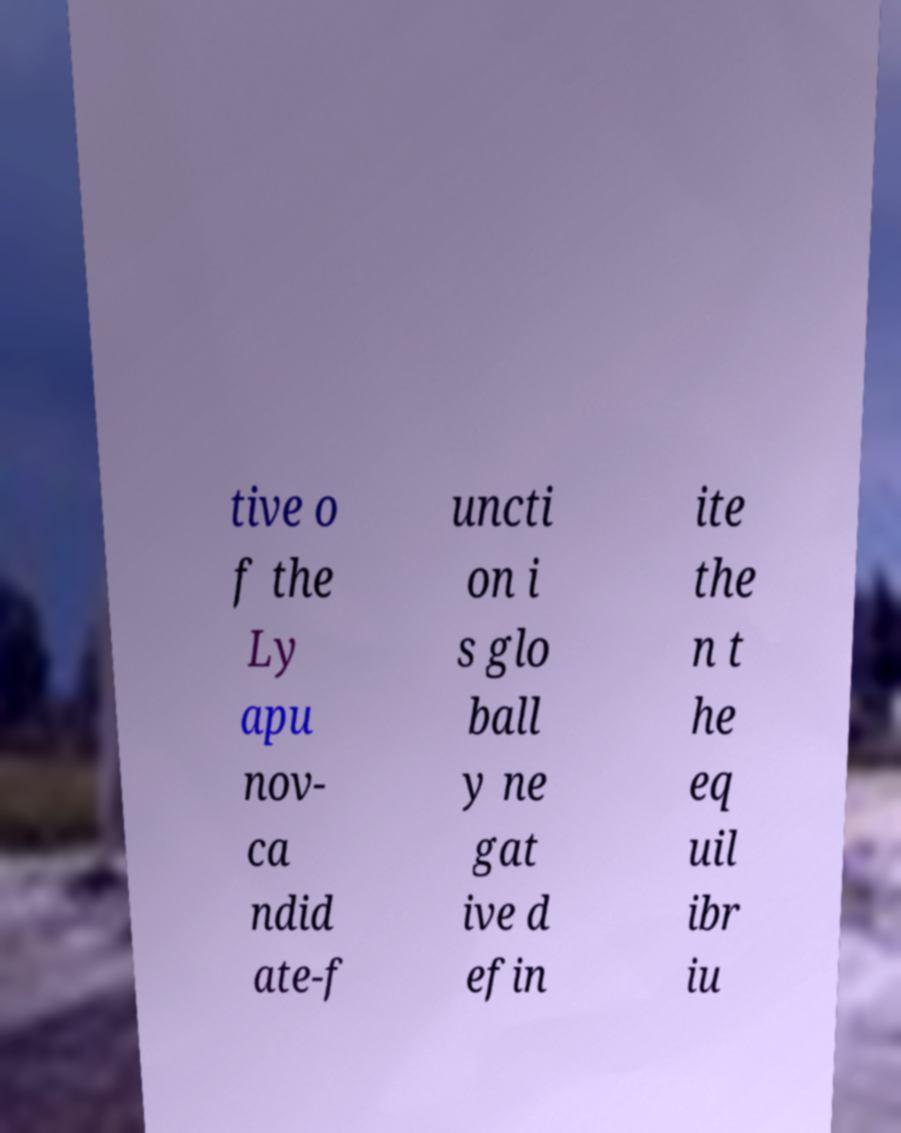For documentation purposes, I need the text within this image transcribed. Could you provide that? tive o f the Ly apu nov- ca ndid ate-f uncti on i s glo ball y ne gat ive d efin ite the n t he eq uil ibr iu 